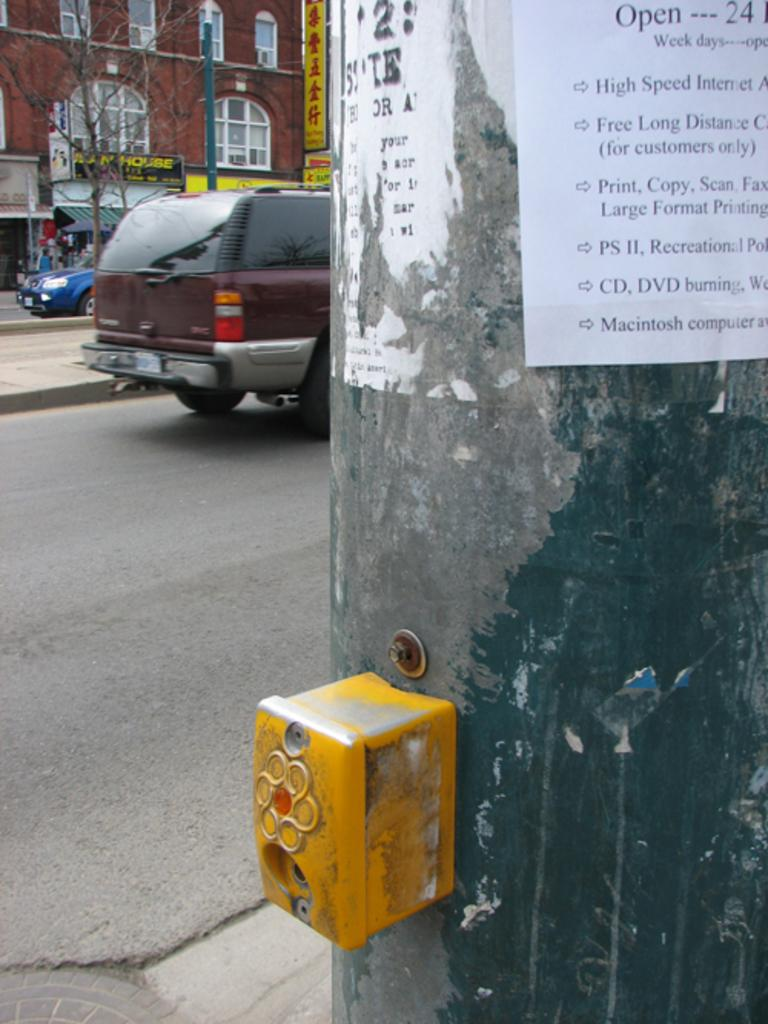What type of structure is visible in the image? There is a building in the image. What natural element can be seen in the image? There is a tree in the image. What mode of transportation can be seen on the road in the image? There are cars on the road in the image. What type of advertisement is present in the image? There are hoardings in the image. What is attached to the pole in the image? There is a paper on a pole in the image. What object can be seen in the image that is not related to the building, tree, cars, hoardings, or paper on a pole? There is a box in the image. What type of soup is being served in the image? There is no soup present in the image. What direction does the building face in the image? The direction the building faces cannot be determined from the image. 